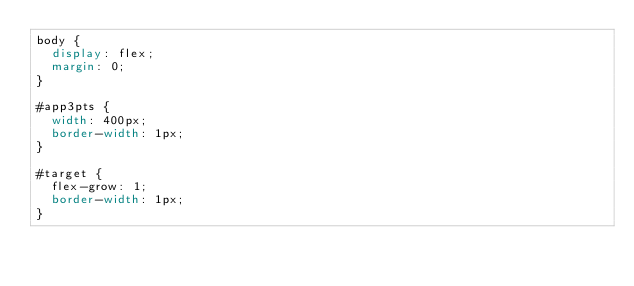Convert code to text. <code><loc_0><loc_0><loc_500><loc_500><_CSS_>body {
  display: flex;
  margin: 0;
}

#app3pts {
  width: 400px;
  border-width: 1px;
}

#target {
  flex-grow: 1;
  border-width: 1px;
}
</code> 